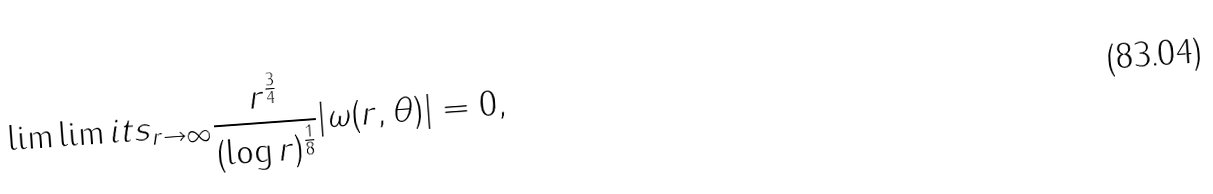<formula> <loc_0><loc_0><loc_500><loc_500>\lim \lim i t s _ { r \to \infty } \frac { r ^ { \frac { 3 } { 4 } } } { ( \log r ) ^ { \frac { 1 } { 8 } } } | \omega ( r , \theta ) | = 0 ,</formula> 